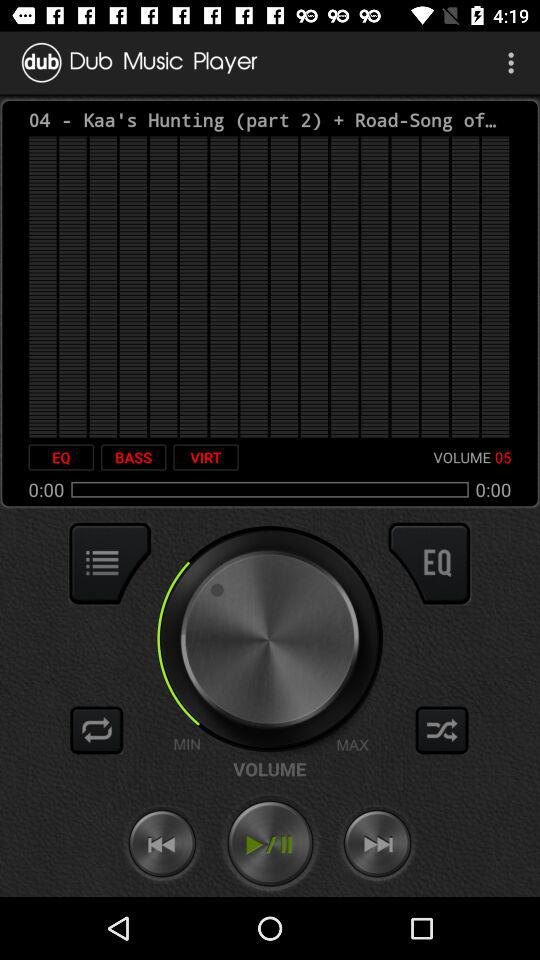What is the volume of the music? The volume of the music is 5. 